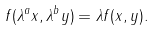<formula> <loc_0><loc_0><loc_500><loc_500>f ( \lambda ^ { a } x , \lambda ^ { b } y ) = \lambda f ( x , y ) .</formula> 